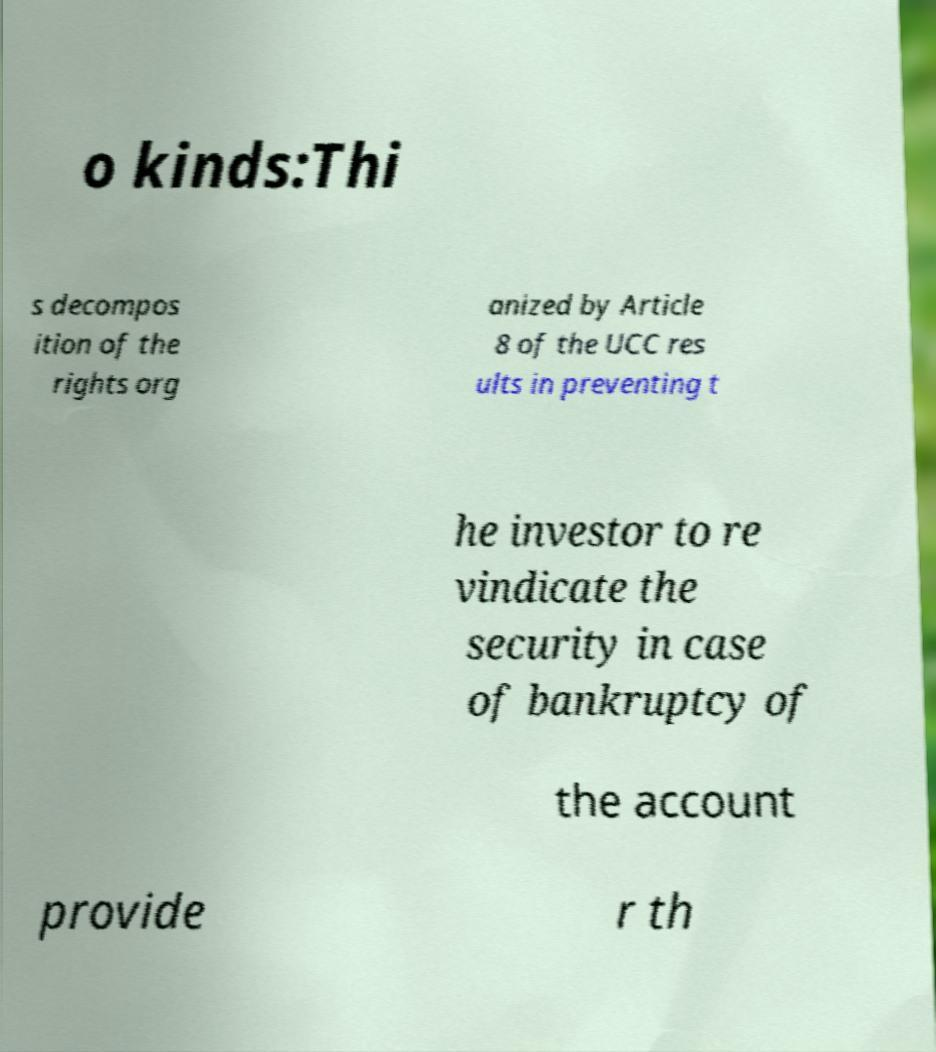Could you assist in decoding the text presented in this image and type it out clearly? o kinds:Thi s decompos ition of the rights org anized by Article 8 of the UCC res ults in preventing t he investor to re vindicate the security in case of bankruptcy of the account provide r th 